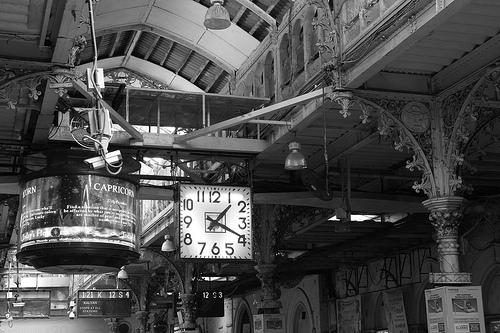Describe the format and setting of the image. The image is in black and white and is taken indoors, showcasing a square clock on the ceiling. What is the central focus of the image? The main focus of the image is a square-shaped clock that hangs from the ceiling. Describe the scene captured in the image in a single sentence. The indoor scene showcases a square clock hanging on the ceiling, surrounded by ornate architectural details and other hanging signs. Write a concise description of the primary subject in the image. A square white clock with black hands and numbers is the main subject in the black and white indoor scene. Mention the key elements of the image and their position. The image has a black and white square clock on the ceiling, ornate architectural details, and other hanging signs. Write a brief description of the primary object in the image. A black and white square-shaped clock with black hands is hanging on the ceiling. State the primary object in the image and any unique features it has. The main object is a square clock with black hands and numbers, hanging from the ceiling. Outline the main elements within the image in a simple sentence. There's a square clock on the ceiling, ornate architectural details, and other hanging signs. Mention one detail about the main object in the photograph and where it's located. The square-shaped clock is hanging from the ceiling. Write a brief sentence mentioning the main object in the image and its color. The primary object in the image is a white square-shaped clock. 